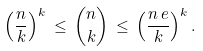Convert formula to latex. <formula><loc_0><loc_0><loc_500><loc_500>\left ( \frac { n } { k } \right ) ^ { k } \, \leq \, { n \choose k } \, \leq \, \left ( \frac { n \, e } { k } \right ) ^ { k } .</formula> 